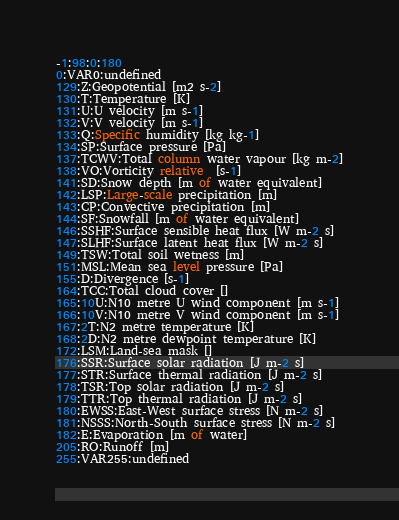<code> <loc_0><loc_0><loc_500><loc_500><_SQL_>-1:98:0:180
0:VAR0:undefined
129:Z:Geopotential [m2 s-2]
130:T:Temperature [K]
131:U:U velocity [m s-1]
132:V:V velocity [m s-1]
133:Q:Specific humidity [kg kg-1]
134:SP:Surface pressure [Pa]
137:TCWV:Total column water vapour [kg m-2]
138:VO:Vorticity relative  [s-1]
141:SD:Snow depth [m of water equivalent]
142:LSP:Large-scale precipitation [m]
143:CP:Convective precipitation [m]
144:SF:Snowfall [m of water equivalent]
146:SSHF:Surface sensible heat flux [W m-2 s]
147:SLHF:Surface latent heat flux [W m-2 s]
149:TSW:Total soil wetness [m]
151:MSL:Mean sea level pressure [Pa]
155:D:Divergence [s-1]
164:TCC:Total cloud cover []
165:10U:N10 metre U wind component [m s-1]
166:10V:N10 metre V wind component [m s-1]
167:2T:N2 metre temperature [K]
168:2D:N2 metre dewpoint temperature [K]
172:LSM:Land-sea mask []
176:SSR:Surface solar radiation [J m-2 s]
177:STR:Surface thermal radiation [J m-2 s]
178:TSR:Top solar radiation [J m-2 s]
179:TTR:Top thermal radiation [J m-2 s]
180:EWSS:East-West surface stress [N m-2 s]
181:NSSS:North-South surface stress [N m-2 s]
182:E:Evaporation [m of water]
205:RO:Runoff [m]
255:VAR255:undefined
</code> 